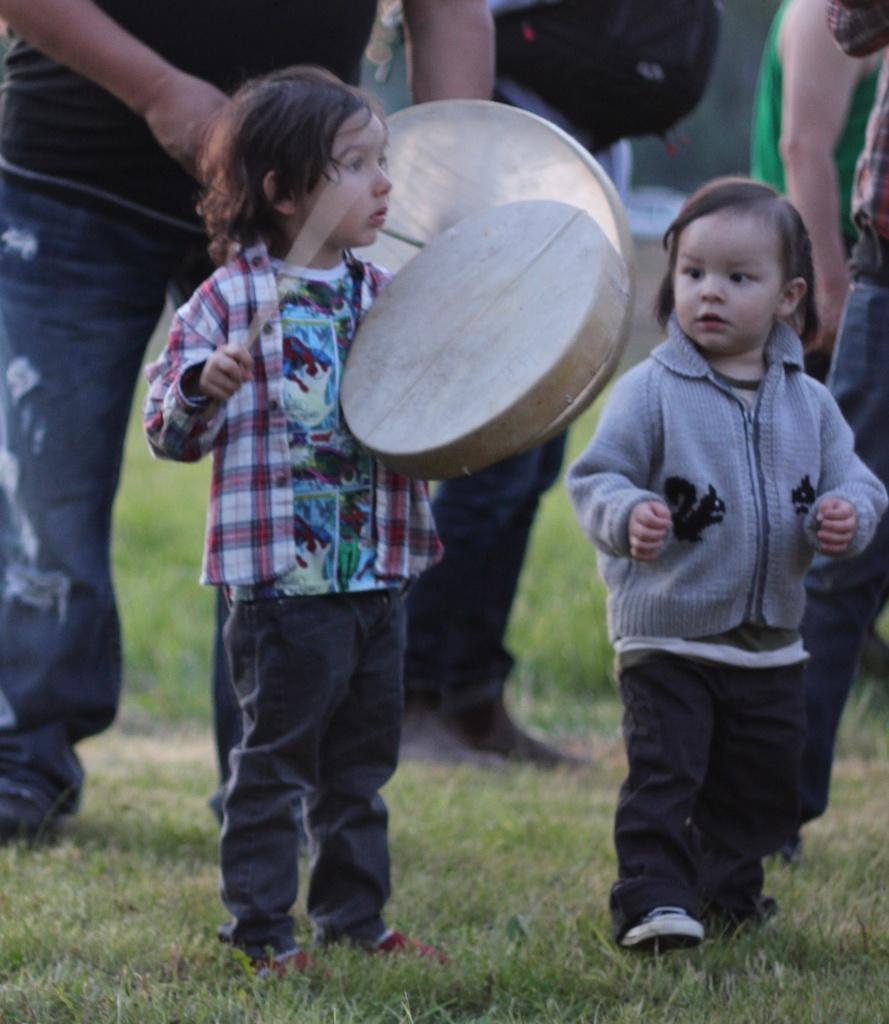How many boys are in the image? There are two boys in the image. What are the boys doing in the image? One boy is playing a drum with a stick. Can you describe the background of the image? There are men in the background of the image. What type of design can be seen on the alley in the image? There is no alley present in the image, so it is not possible to answer that question. 